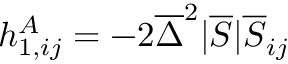Convert formula to latex. <formula><loc_0><loc_0><loc_500><loc_500>h _ { 1 , i j } ^ { A } = - 2 \overline { \Delta } ^ { 2 } | \overline { S } | \overline { S } _ { i j }</formula> 